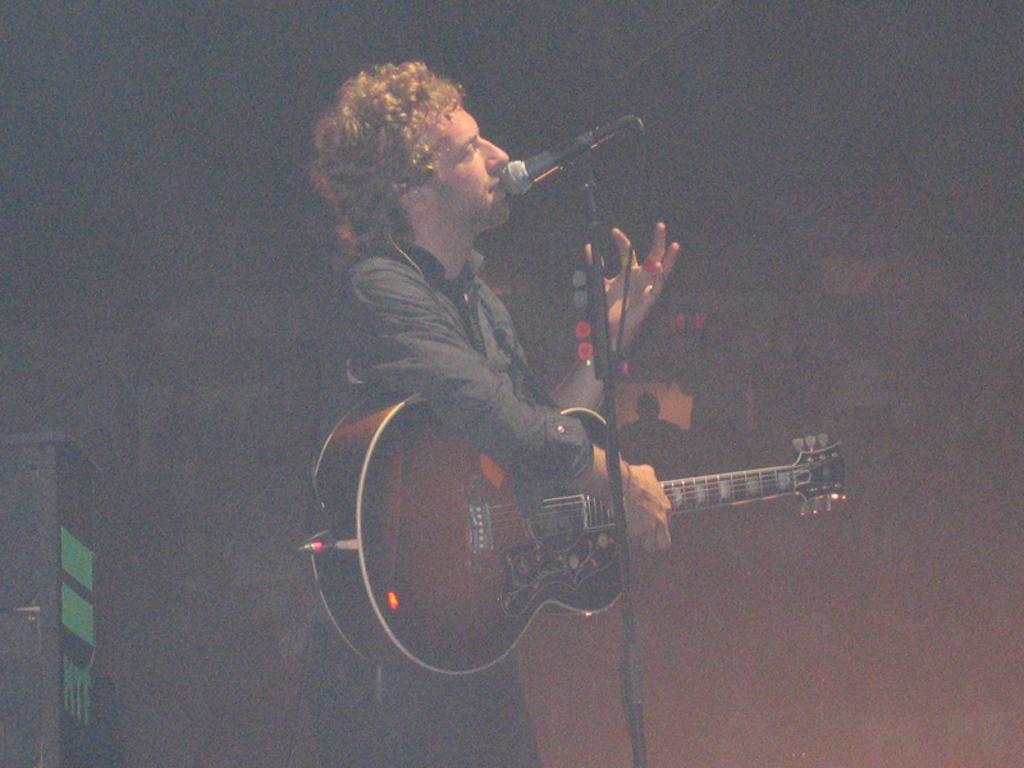Could you give a brief overview of what you see in this image? In this image, there is a person standing and singing a song in front of the mike and playing a guitar. In the background there is a wall painting which is visible. In the left bottom of the image, there is a table which is black in color. This image is taken in a dark place during night time. 